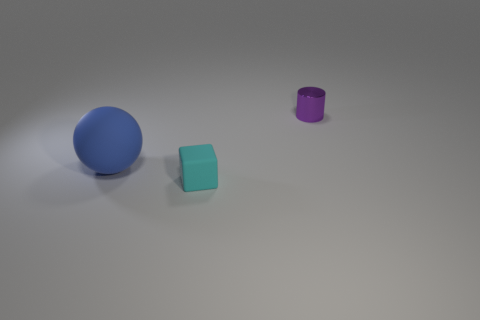What is the relationship between the objects in the image in terms of size and arrangement? The objects are arranged in a descending order of size from left to right, starting with the largest - a blue matte sphere, followed by a smaller teal cube, and ending with the smallest - a purple metallic cylinder. Can you describe the colors and textures of the objects? Certainly! On the left, there's a large blue sphere with a matte finish. In the middle, a teal cube that appears to have a somewhat matte texture as well. On the right, the smallest object is a purple cylinder with a metallic sheen, reflecting some light. 